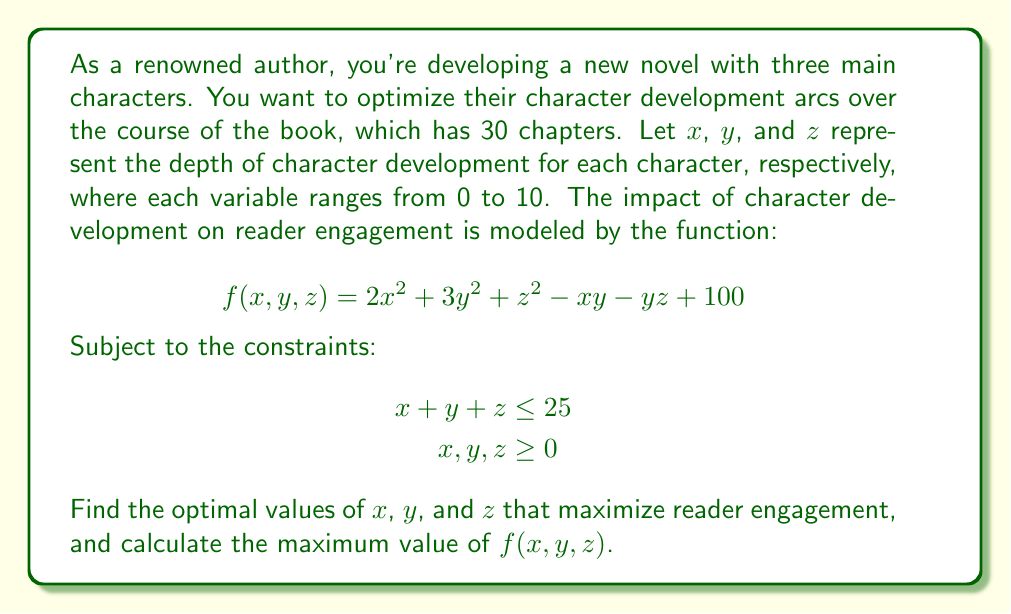Give your solution to this math problem. To solve this optimization problem, we'll use the method of Lagrange multipliers:

1) First, we form the Lagrangian function:
   $$L(x,y,z,\lambda) = 2x^2 + 3y^2 + z^2 - xy - yz + 100 + \lambda(25 - x - y - z)$$

2) Now, we take partial derivatives and set them equal to zero:
   $$\frac{\partial L}{\partial x} = 4x - y - \lambda = 0$$
   $$\frac{\partial L}{\partial y} = 6y - x - z - \lambda = 0$$
   $$\frac{\partial L}{\partial z} = 2z - y - \lambda = 0$$
   $$\frac{\partial L}{\partial \lambda} = 25 - x - y - z = 0$$

3) From the first and third equations:
   $$4x - y = 2z - y$$
   $$4x = 2z$$
   $$x = \frac{1}{2}z$$

4) Substituting this into the second equation:
   $$6y - \frac{1}{2}z - z - \lambda = 0$$
   $$6y - \frac{3}{2}z = \lambda$$

5) From the third equation:
   $$2z - y = \lambda$$

6) Equating these:
   $$6y - \frac{3}{2}z = 2z - y$$
   $$7y = \frac{7}{2}z$$
   $$y = \frac{1}{2}z$$

7) Substituting into the constraint equation:
   $$\frac{1}{2}z + \frac{1}{2}z + z = 25$$
   $$2z = 25$$
   $$z = 12.5$$

8) Therefore:
   $$x = \frac{1}{2}(12.5) = 6.25$$
   $$y = \frac{1}{2}(12.5) = 6.25$$
   $$z = 12.5$$

9) To verify this is a maximum, we can check the second derivatives, which confirm this is indeed a local maximum.

10) The maximum value of $f(x,y,z)$ is:
    $$f(6.25, 6.25, 12.5) = 2(6.25)^2 + 3(6.25)^2 + (12.5)^2 - (6.25)(6.25) - (6.25)(12.5) + 100$$
    $$= 78.125 + 117.1875 + 156.25 - 39.0625 - 78.125 + 100$$
    $$= 334.375$$
Answer: The optimal values are $x = 6.25$, $y = 6.25$, and $z = 12.5$. The maximum value of $f(x,y,z)$ is 334.375. 